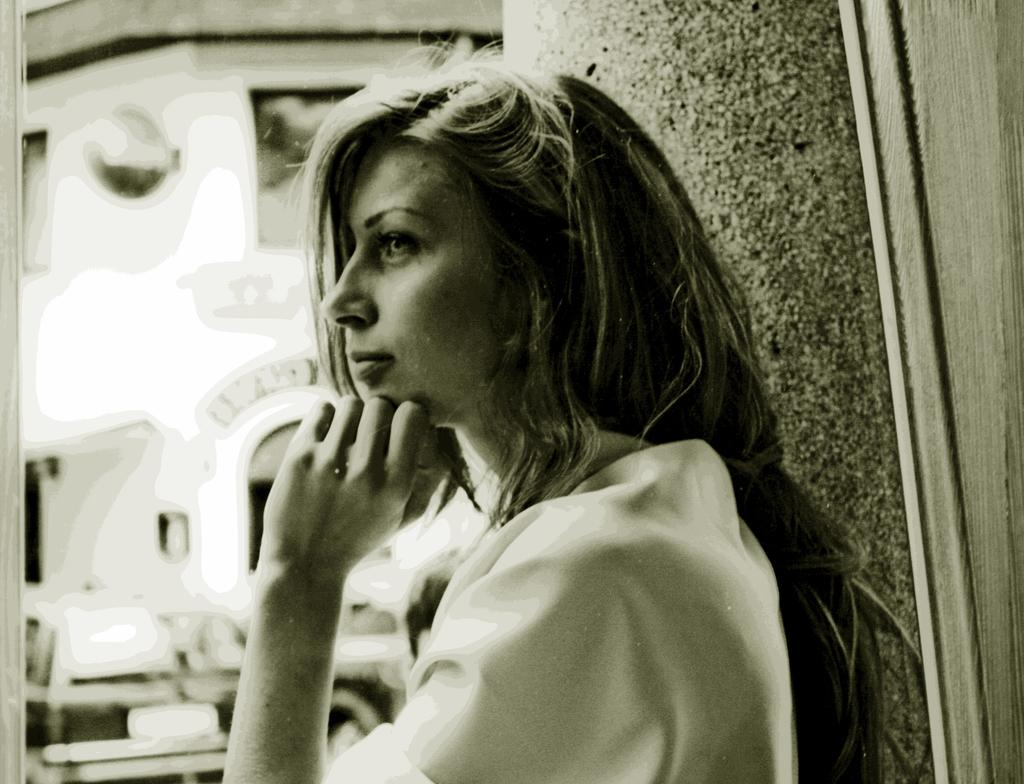Who is present in the image? There is a woman in the image. What type of hydrant is the woman using in the image? There is no hydrant present in the image; it only features a woman. What is the woman's income in the image? The image does not provide any information about the woman's income. 